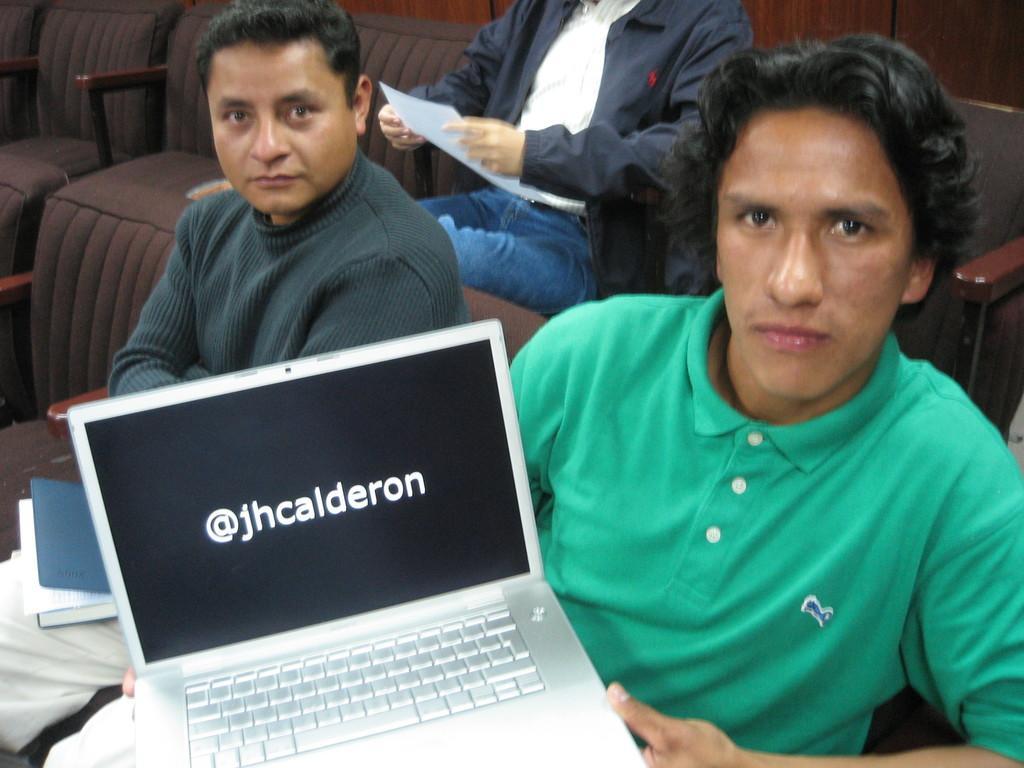Please provide a concise description of this image. In this picture there is a man who is wearing green t-shirt and holding the laptop. beside him we can see another man who is holding the book. In the back there is another man who is sitting on the couch near to the wall. 